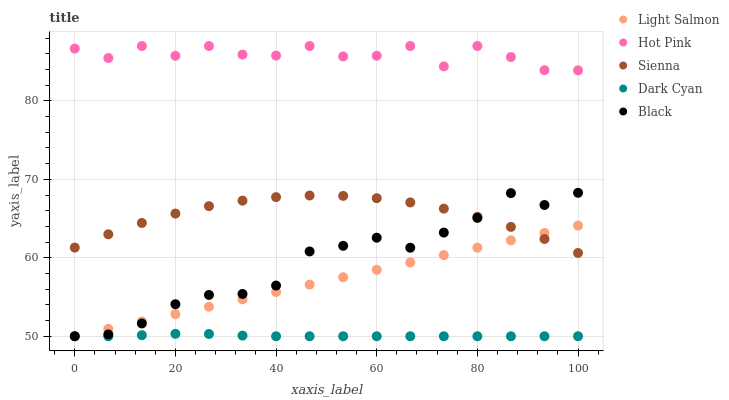Does Dark Cyan have the minimum area under the curve?
Answer yes or no. Yes. Does Hot Pink have the maximum area under the curve?
Answer yes or no. Yes. Does Light Salmon have the minimum area under the curve?
Answer yes or no. No. Does Light Salmon have the maximum area under the curve?
Answer yes or no. No. Is Light Salmon the smoothest?
Answer yes or no. Yes. Is Hot Pink the roughest?
Answer yes or no. Yes. Is Dark Cyan the smoothest?
Answer yes or no. No. Is Dark Cyan the roughest?
Answer yes or no. No. Does Dark Cyan have the lowest value?
Answer yes or no. Yes. Does Hot Pink have the lowest value?
Answer yes or no. No. Does Hot Pink have the highest value?
Answer yes or no. Yes. Does Light Salmon have the highest value?
Answer yes or no. No. Is Dark Cyan less than Sienna?
Answer yes or no. Yes. Is Hot Pink greater than Sienna?
Answer yes or no. Yes. Does Black intersect Dark Cyan?
Answer yes or no. Yes. Is Black less than Dark Cyan?
Answer yes or no. No. Is Black greater than Dark Cyan?
Answer yes or no. No. Does Dark Cyan intersect Sienna?
Answer yes or no. No. 